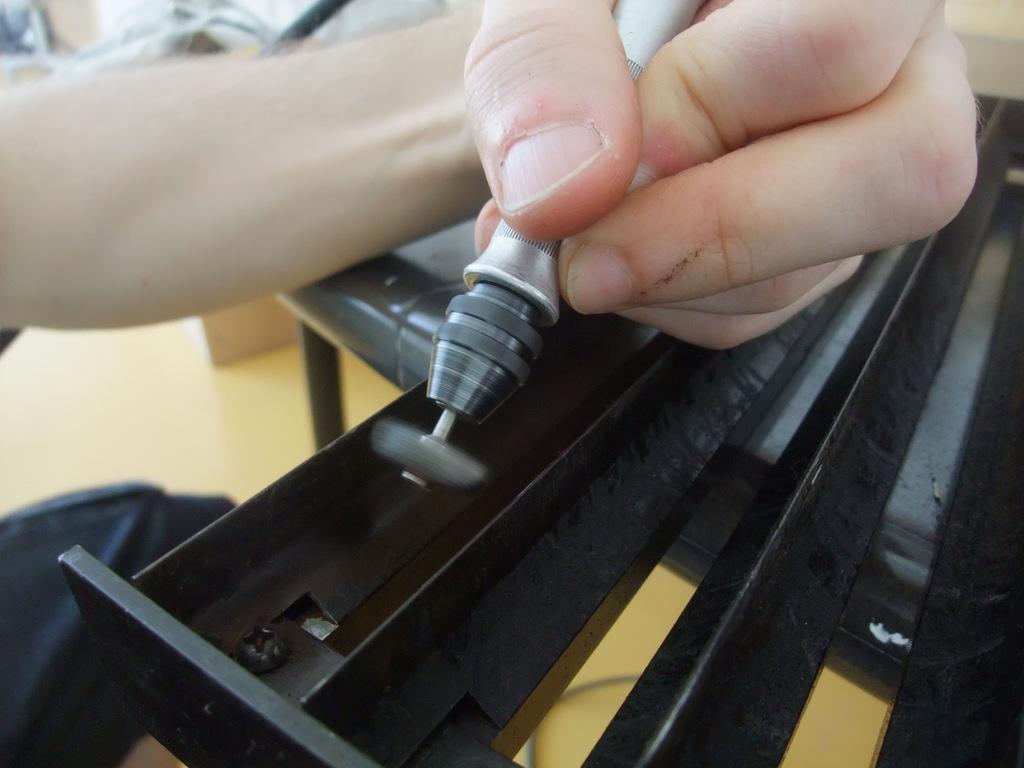Describe this image in one or two sentences. In this image I can see the person holding the tool which is in grey and silver color and I can see the black color iron rod. In the back there is a brown color floor. 